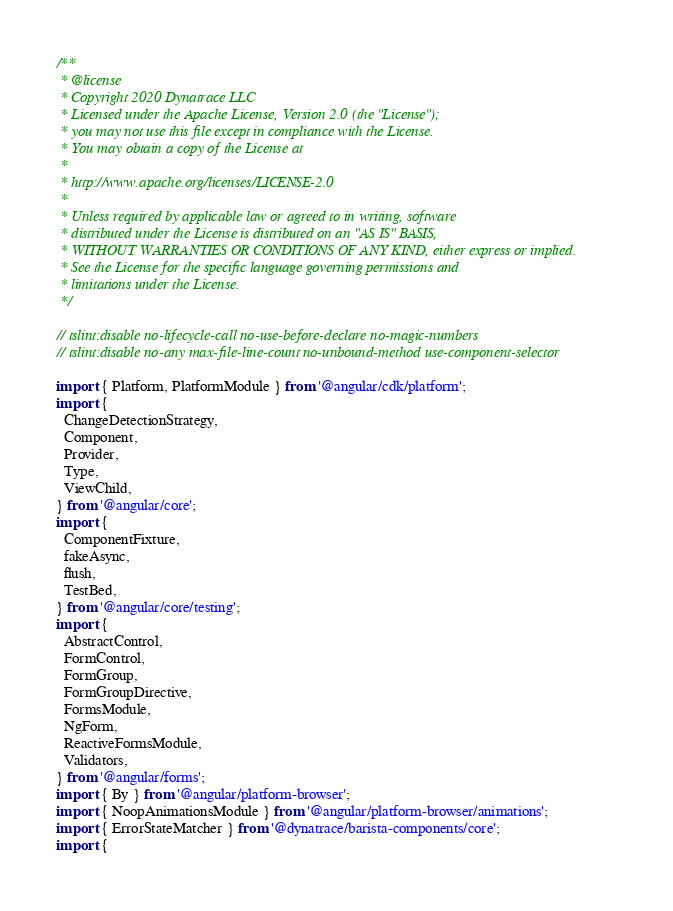Convert code to text. <code><loc_0><loc_0><loc_500><loc_500><_TypeScript_>/**
 * @license
 * Copyright 2020 Dynatrace LLC
 * Licensed under the Apache License, Version 2.0 (the "License");
 * you may not use this file except in compliance with the License.
 * You may obtain a copy of the License at
 *
 * http://www.apache.org/licenses/LICENSE-2.0
 *
 * Unless required by applicable law or agreed to in writing, software
 * distributed under the License is distributed on an "AS IS" BASIS,
 * WITHOUT WARRANTIES OR CONDITIONS OF ANY KIND, either express or implied.
 * See the License for the specific language governing permissions and
 * limitations under the License.
 */

// tslint:disable no-lifecycle-call no-use-before-declare no-magic-numbers
// tslint:disable no-any max-file-line-count no-unbound-method use-component-selector

import { Platform, PlatformModule } from '@angular/cdk/platform';
import {
  ChangeDetectionStrategy,
  Component,
  Provider,
  Type,
  ViewChild,
} from '@angular/core';
import {
  ComponentFixture,
  fakeAsync,
  flush,
  TestBed,
} from '@angular/core/testing';
import {
  AbstractControl,
  FormControl,
  FormGroup,
  FormGroupDirective,
  FormsModule,
  NgForm,
  ReactiveFormsModule,
  Validators,
} from '@angular/forms';
import { By } from '@angular/platform-browser';
import { NoopAnimationsModule } from '@angular/platform-browser/animations';
import { ErrorStateMatcher } from '@dynatrace/barista-components/core';
import {</code> 